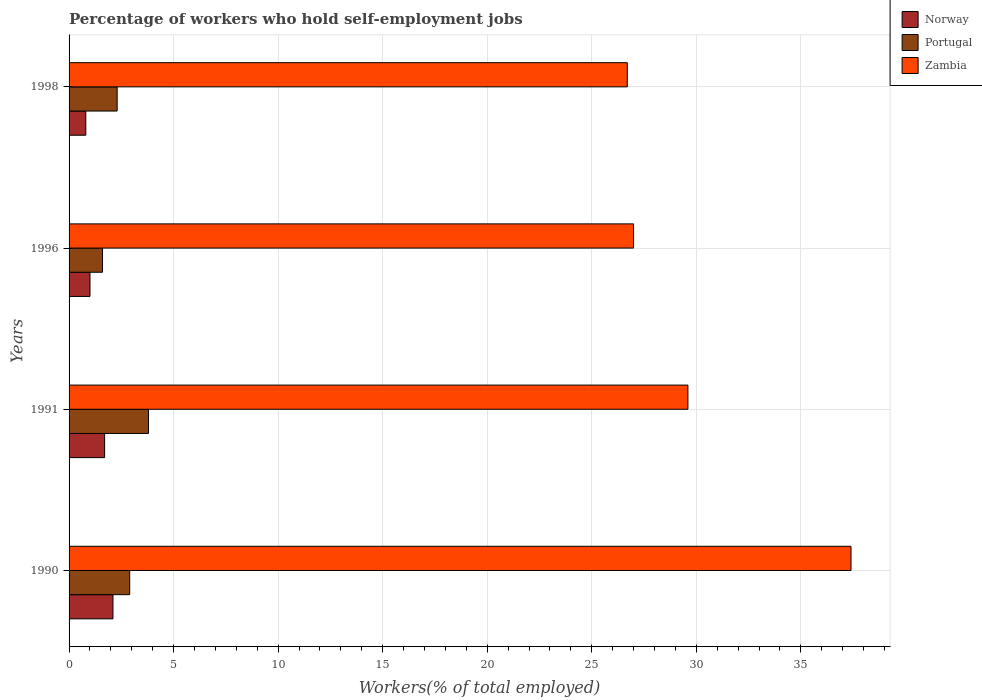How many different coloured bars are there?
Make the answer very short. 3. Are the number of bars per tick equal to the number of legend labels?
Your answer should be compact. Yes. Are the number of bars on each tick of the Y-axis equal?
Your answer should be compact. Yes. How many bars are there on the 2nd tick from the top?
Keep it short and to the point. 3. What is the label of the 2nd group of bars from the top?
Offer a terse response. 1996. Across all years, what is the maximum percentage of self-employed workers in Zambia?
Provide a succinct answer. 37.4. Across all years, what is the minimum percentage of self-employed workers in Norway?
Your answer should be very brief. 0.8. In which year was the percentage of self-employed workers in Norway maximum?
Offer a terse response. 1990. In which year was the percentage of self-employed workers in Zambia minimum?
Your response must be concise. 1998. What is the total percentage of self-employed workers in Portugal in the graph?
Keep it short and to the point. 10.6. What is the difference between the percentage of self-employed workers in Norway in 1990 and that in 1991?
Offer a terse response. 0.4. What is the difference between the percentage of self-employed workers in Norway in 1996 and the percentage of self-employed workers in Portugal in 1998?
Your answer should be compact. -1.3. What is the average percentage of self-employed workers in Zambia per year?
Your answer should be compact. 30.18. In the year 1990, what is the difference between the percentage of self-employed workers in Norway and percentage of self-employed workers in Zambia?
Keep it short and to the point. -35.3. In how many years, is the percentage of self-employed workers in Portugal greater than 14 %?
Provide a succinct answer. 0. What is the ratio of the percentage of self-employed workers in Zambia in 1991 to that in 1996?
Keep it short and to the point. 1.1. What is the difference between the highest and the second highest percentage of self-employed workers in Norway?
Offer a terse response. 0.4. What is the difference between the highest and the lowest percentage of self-employed workers in Norway?
Your answer should be very brief. 1.3. Is the sum of the percentage of self-employed workers in Portugal in 1990 and 1998 greater than the maximum percentage of self-employed workers in Zambia across all years?
Your response must be concise. No. What does the 2nd bar from the top in 1990 represents?
Give a very brief answer. Portugal. How many years are there in the graph?
Ensure brevity in your answer.  4. Does the graph contain any zero values?
Keep it short and to the point. No. Does the graph contain grids?
Provide a short and direct response. Yes. Where does the legend appear in the graph?
Your answer should be compact. Top right. How many legend labels are there?
Your answer should be very brief. 3. What is the title of the graph?
Provide a succinct answer. Percentage of workers who hold self-employment jobs. Does "World" appear as one of the legend labels in the graph?
Keep it short and to the point. No. What is the label or title of the X-axis?
Make the answer very short. Workers(% of total employed). What is the label or title of the Y-axis?
Your answer should be very brief. Years. What is the Workers(% of total employed) in Norway in 1990?
Your answer should be very brief. 2.1. What is the Workers(% of total employed) of Portugal in 1990?
Provide a short and direct response. 2.9. What is the Workers(% of total employed) in Zambia in 1990?
Make the answer very short. 37.4. What is the Workers(% of total employed) of Norway in 1991?
Keep it short and to the point. 1.7. What is the Workers(% of total employed) in Portugal in 1991?
Your answer should be compact. 3.8. What is the Workers(% of total employed) of Zambia in 1991?
Keep it short and to the point. 29.6. What is the Workers(% of total employed) in Norway in 1996?
Make the answer very short. 1. What is the Workers(% of total employed) in Portugal in 1996?
Your response must be concise. 1.6. What is the Workers(% of total employed) in Zambia in 1996?
Give a very brief answer. 27. What is the Workers(% of total employed) in Norway in 1998?
Ensure brevity in your answer.  0.8. What is the Workers(% of total employed) of Portugal in 1998?
Offer a very short reply. 2.3. What is the Workers(% of total employed) of Zambia in 1998?
Ensure brevity in your answer.  26.7. Across all years, what is the maximum Workers(% of total employed) in Norway?
Keep it short and to the point. 2.1. Across all years, what is the maximum Workers(% of total employed) in Portugal?
Your answer should be compact. 3.8. Across all years, what is the maximum Workers(% of total employed) of Zambia?
Offer a very short reply. 37.4. Across all years, what is the minimum Workers(% of total employed) of Norway?
Provide a succinct answer. 0.8. Across all years, what is the minimum Workers(% of total employed) of Portugal?
Keep it short and to the point. 1.6. Across all years, what is the minimum Workers(% of total employed) of Zambia?
Keep it short and to the point. 26.7. What is the total Workers(% of total employed) in Norway in the graph?
Your response must be concise. 5.6. What is the total Workers(% of total employed) of Portugal in the graph?
Offer a very short reply. 10.6. What is the total Workers(% of total employed) in Zambia in the graph?
Offer a terse response. 120.7. What is the difference between the Workers(% of total employed) in Norway in 1990 and that in 1991?
Your answer should be compact. 0.4. What is the difference between the Workers(% of total employed) in Zambia in 1990 and that in 1991?
Your response must be concise. 7.8. What is the difference between the Workers(% of total employed) of Norway in 1990 and that in 1996?
Give a very brief answer. 1.1. What is the difference between the Workers(% of total employed) in Zambia in 1990 and that in 1996?
Make the answer very short. 10.4. What is the difference between the Workers(% of total employed) of Norway in 1990 and that in 1998?
Your response must be concise. 1.3. What is the difference between the Workers(% of total employed) of Zambia in 1990 and that in 1998?
Your answer should be very brief. 10.7. What is the difference between the Workers(% of total employed) of Norway in 1991 and that in 1996?
Your response must be concise. 0.7. What is the difference between the Workers(% of total employed) of Zambia in 1991 and that in 1996?
Ensure brevity in your answer.  2.6. What is the difference between the Workers(% of total employed) in Portugal in 1991 and that in 1998?
Provide a short and direct response. 1.5. What is the difference between the Workers(% of total employed) in Zambia in 1991 and that in 1998?
Provide a succinct answer. 2.9. What is the difference between the Workers(% of total employed) in Norway in 1990 and the Workers(% of total employed) in Zambia in 1991?
Keep it short and to the point. -27.5. What is the difference between the Workers(% of total employed) in Portugal in 1990 and the Workers(% of total employed) in Zambia in 1991?
Keep it short and to the point. -26.7. What is the difference between the Workers(% of total employed) in Norway in 1990 and the Workers(% of total employed) in Zambia in 1996?
Provide a short and direct response. -24.9. What is the difference between the Workers(% of total employed) in Portugal in 1990 and the Workers(% of total employed) in Zambia in 1996?
Keep it short and to the point. -24.1. What is the difference between the Workers(% of total employed) in Norway in 1990 and the Workers(% of total employed) in Zambia in 1998?
Ensure brevity in your answer.  -24.6. What is the difference between the Workers(% of total employed) of Portugal in 1990 and the Workers(% of total employed) of Zambia in 1998?
Your response must be concise. -23.8. What is the difference between the Workers(% of total employed) in Norway in 1991 and the Workers(% of total employed) in Portugal in 1996?
Provide a succinct answer. 0.1. What is the difference between the Workers(% of total employed) in Norway in 1991 and the Workers(% of total employed) in Zambia in 1996?
Ensure brevity in your answer.  -25.3. What is the difference between the Workers(% of total employed) in Portugal in 1991 and the Workers(% of total employed) in Zambia in 1996?
Your response must be concise. -23.2. What is the difference between the Workers(% of total employed) in Norway in 1991 and the Workers(% of total employed) in Zambia in 1998?
Your answer should be very brief. -25. What is the difference between the Workers(% of total employed) of Portugal in 1991 and the Workers(% of total employed) of Zambia in 1998?
Offer a terse response. -22.9. What is the difference between the Workers(% of total employed) in Norway in 1996 and the Workers(% of total employed) in Portugal in 1998?
Provide a succinct answer. -1.3. What is the difference between the Workers(% of total employed) in Norway in 1996 and the Workers(% of total employed) in Zambia in 1998?
Provide a succinct answer. -25.7. What is the difference between the Workers(% of total employed) of Portugal in 1996 and the Workers(% of total employed) of Zambia in 1998?
Ensure brevity in your answer.  -25.1. What is the average Workers(% of total employed) of Norway per year?
Your response must be concise. 1.4. What is the average Workers(% of total employed) in Portugal per year?
Offer a very short reply. 2.65. What is the average Workers(% of total employed) of Zambia per year?
Give a very brief answer. 30.18. In the year 1990, what is the difference between the Workers(% of total employed) of Norway and Workers(% of total employed) of Zambia?
Offer a terse response. -35.3. In the year 1990, what is the difference between the Workers(% of total employed) in Portugal and Workers(% of total employed) in Zambia?
Provide a succinct answer. -34.5. In the year 1991, what is the difference between the Workers(% of total employed) of Norway and Workers(% of total employed) of Portugal?
Offer a terse response. -2.1. In the year 1991, what is the difference between the Workers(% of total employed) in Norway and Workers(% of total employed) in Zambia?
Provide a short and direct response. -27.9. In the year 1991, what is the difference between the Workers(% of total employed) in Portugal and Workers(% of total employed) in Zambia?
Your answer should be very brief. -25.8. In the year 1996, what is the difference between the Workers(% of total employed) of Portugal and Workers(% of total employed) of Zambia?
Keep it short and to the point. -25.4. In the year 1998, what is the difference between the Workers(% of total employed) of Norway and Workers(% of total employed) of Zambia?
Keep it short and to the point. -25.9. In the year 1998, what is the difference between the Workers(% of total employed) in Portugal and Workers(% of total employed) in Zambia?
Offer a very short reply. -24.4. What is the ratio of the Workers(% of total employed) in Norway in 1990 to that in 1991?
Provide a short and direct response. 1.24. What is the ratio of the Workers(% of total employed) of Portugal in 1990 to that in 1991?
Give a very brief answer. 0.76. What is the ratio of the Workers(% of total employed) in Zambia in 1990 to that in 1991?
Provide a succinct answer. 1.26. What is the ratio of the Workers(% of total employed) in Norway in 1990 to that in 1996?
Ensure brevity in your answer.  2.1. What is the ratio of the Workers(% of total employed) in Portugal in 1990 to that in 1996?
Ensure brevity in your answer.  1.81. What is the ratio of the Workers(% of total employed) of Zambia in 1990 to that in 1996?
Provide a succinct answer. 1.39. What is the ratio of the Workers(% of total employed) in Norway in 1990 to that in 1998?
Your answer should be compact. 2.62. What is the ratio of the Workers(% of total employed) in Portugal in 1990 to that in 1998?
Make the answer very short. 1.26. What is the ratio of the Workers(% of total employed) of Zambia in 1990 to that in 1998?
Your answer should be compact. 1.4. What is the ratio of the Workers(% of total employed) in Portugal in 1991 to that in 1996?
Keep it short and to the point. 2.38. What is the ratio of the Workers(% of total employed) of Zambia in 1991 to that in 1996?
Offer a very short reply. 1.1. What is the ratio of the Workers(% of total employed) in Norway in 1991 to that in 1998?
Keep it short and to the point. 2.12. What is the ratio of the Workers(% of total employed) of Portugal in 1991 to that in 1998?
Your answer should be very brief. 1.65. What is the ratio of the Workers(% of total employed) in Zambia in 1991 to that in 1998?
Provide a succinct answer. 1.11. What is the ratio of the Workers(% of total employed) of Norway in 1996 to that in 1998?
Offer a very short reply. 1.25. What is the ratio of the Workers(% of total employed) in Portugal in 1996 to that in 1998?
Keep it short and to the point. 0.7. What is the ratio of the Workers(% of total employed) of Zambia in 1996 to that in 1998?
Your answer should be very brief. 1.01. What is the difference between the highest and the second highest Workers(% of total employed) in Norway?
Offer a terse response. 0.4. What is the difference between the highest and the second highest Workers(% of total employed) of Zambia?
Make the answer very short. 7.8. What is the difference between the highest and the lowest Workers(% of total employed) in Norway?
Offer a terse response. 1.3. What is the difference between the highest and the lowest Workers(% of total employed) in Portugal?
Ensure brevity in your answer.  2.2. 